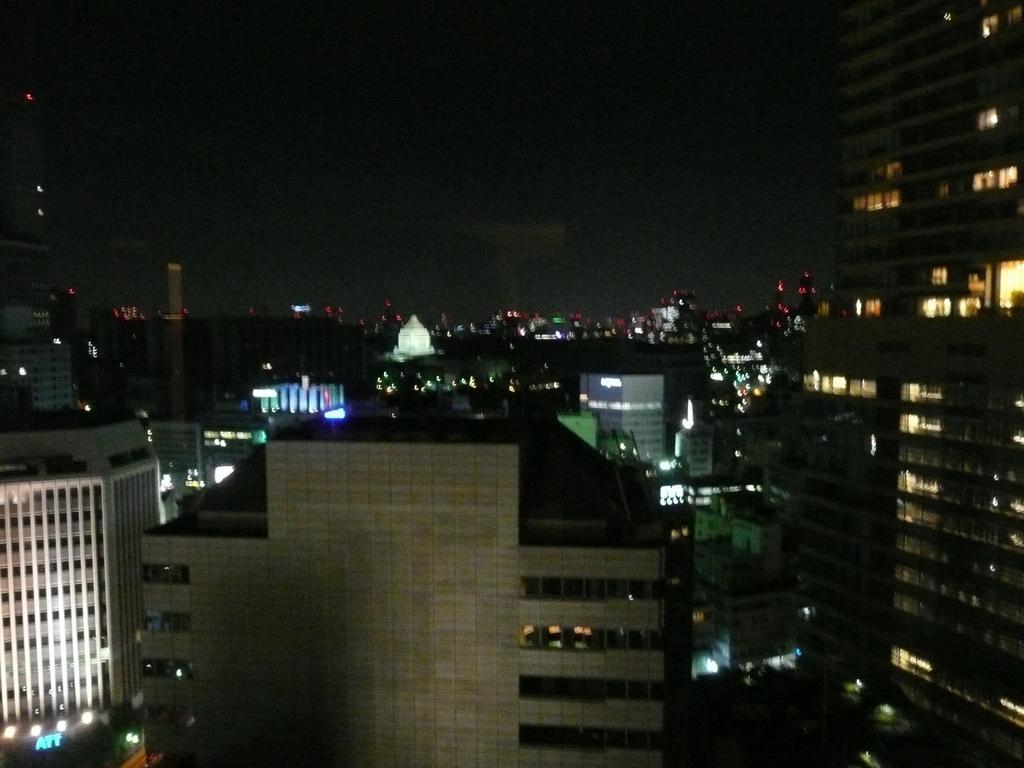Could you give a brief overview of what you see in this image? The image is an aerial view of a city. In this picture we can see buildings and lights. Sky is dark. 